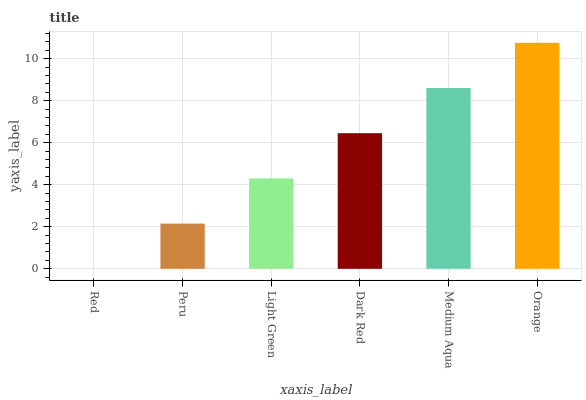Is Red the minimum?
Answer yes or no. Yes. Is Orange the maximum?
Answer yes or no. Yes. Is Peru the minimum?
Answer yes or no. No. Is Peru the maximum?
Answer yes or no. No. Is Peru greater than Red?
Answer yes or no. Yes. Is Red less than Peru?
Answer yes or no. Yes. Is Red greater than Peru?
Answer yes or no. No. Is Peru less than Red?
Answer yes or no. No. Is Dark Red the high median?
Answer yes or no. Yes. Is Light Green the low median?
Answer yes or no. Yes. Is Medium Aqua the high median?
Answer yes or no. No. Is Orange the low median?
Answer yes or no. No. 